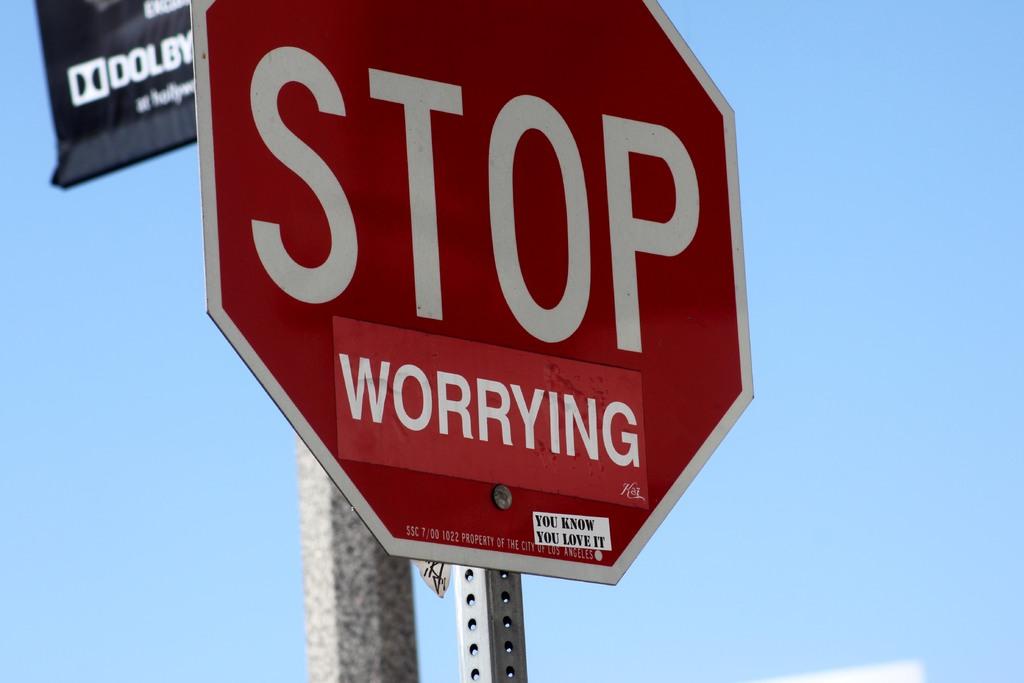What does the red sticker say?
Keep it short and to the point. Worrying. What kind of sign is this?
Offer a terse response. Stop. 